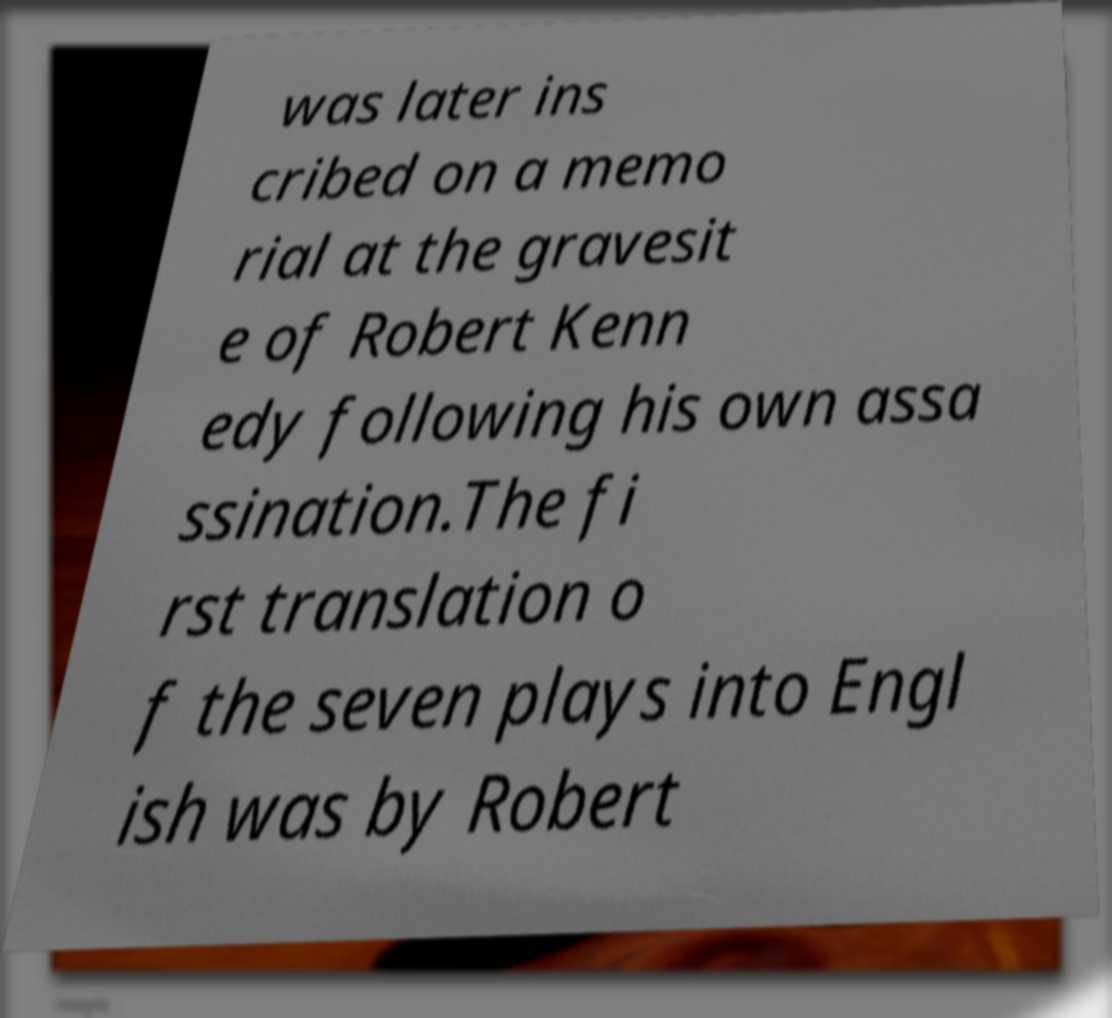What messages or text are displayed in this image? I need them in a readable, typed format. was later ins cribed on a memo rial at the gravesit e of Robert Kenn edy following his own assa ssination.The fi rst translation o f the seven plays into Engl ish was by Robert 